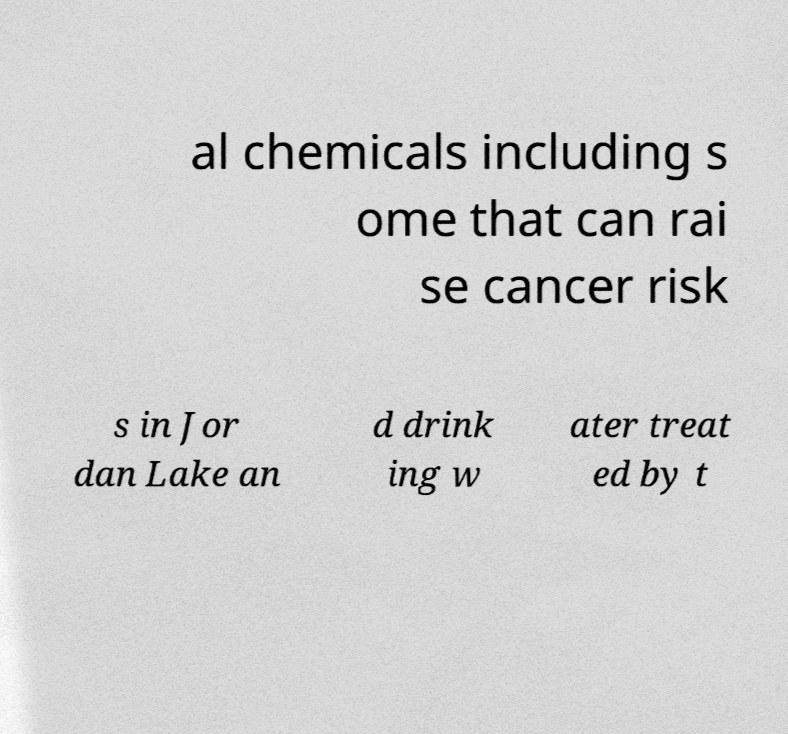What messages or text are displayed in this image? I need them in a readable, typed format. al chemicals including s ome that can rai se cancer risk s in Jor dan Lake an d drink ing w ater treat ed by t 